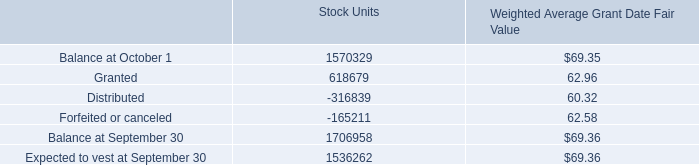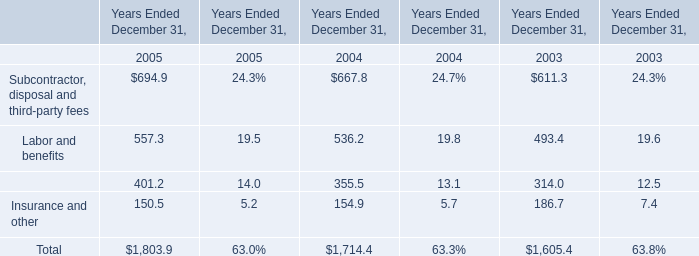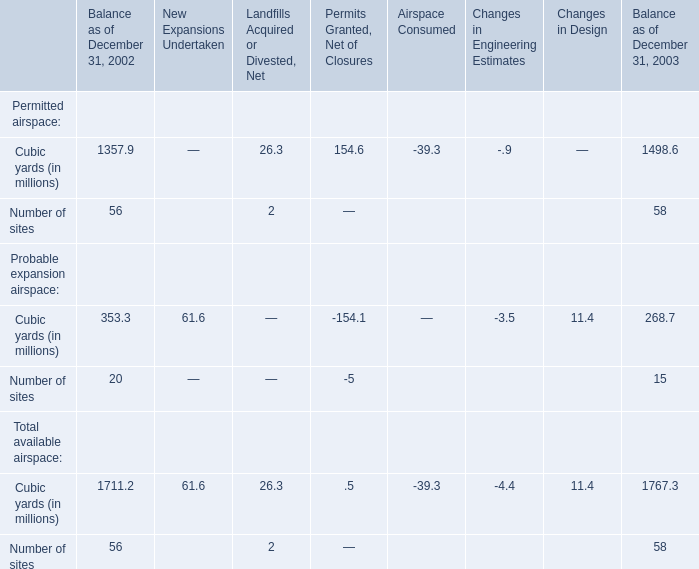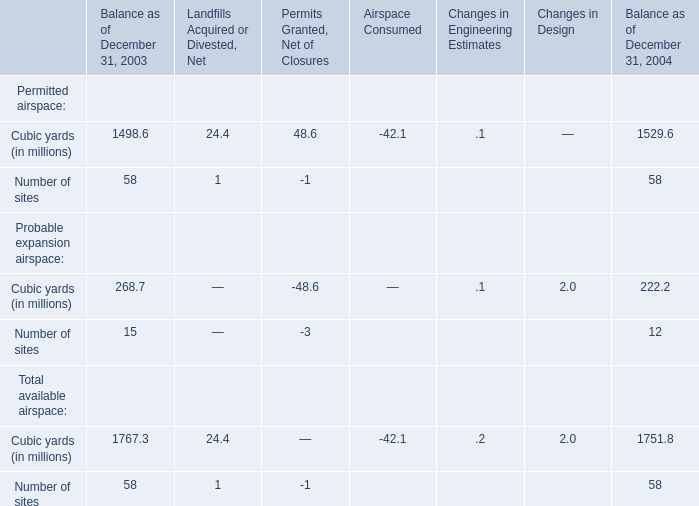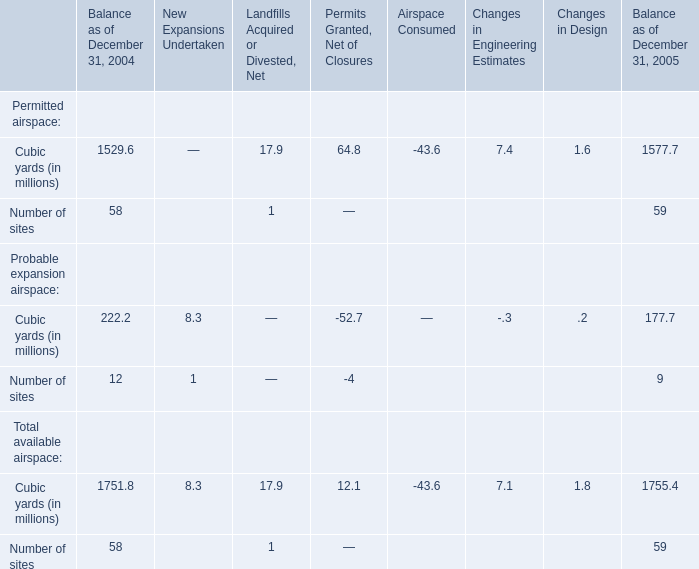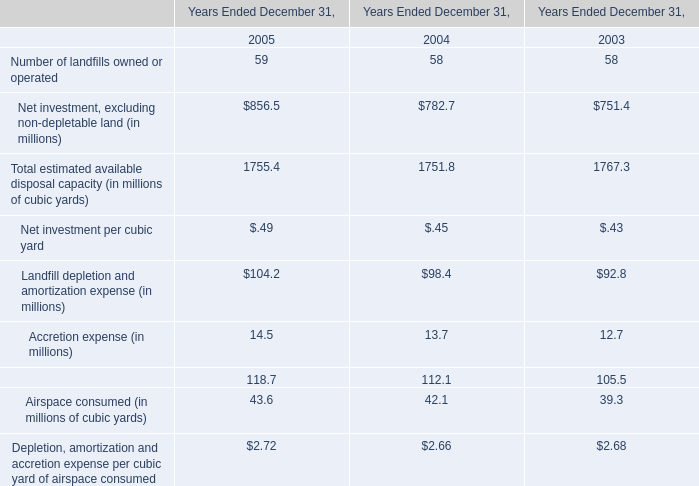What's the Balance as of December 31, 2003 for Cubic yards in terms of Total available airspace as As the chart 3 shows? (in million) 
Answer: 1767.3. 